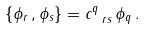<formula> <loc_0><loc_0><loc_500><loc_500>\{ \phi _ { r } \, , \phi _ { s } \} = c ^ { q } _ { \ r s } \, \phi _ { q } \, .</formula> 